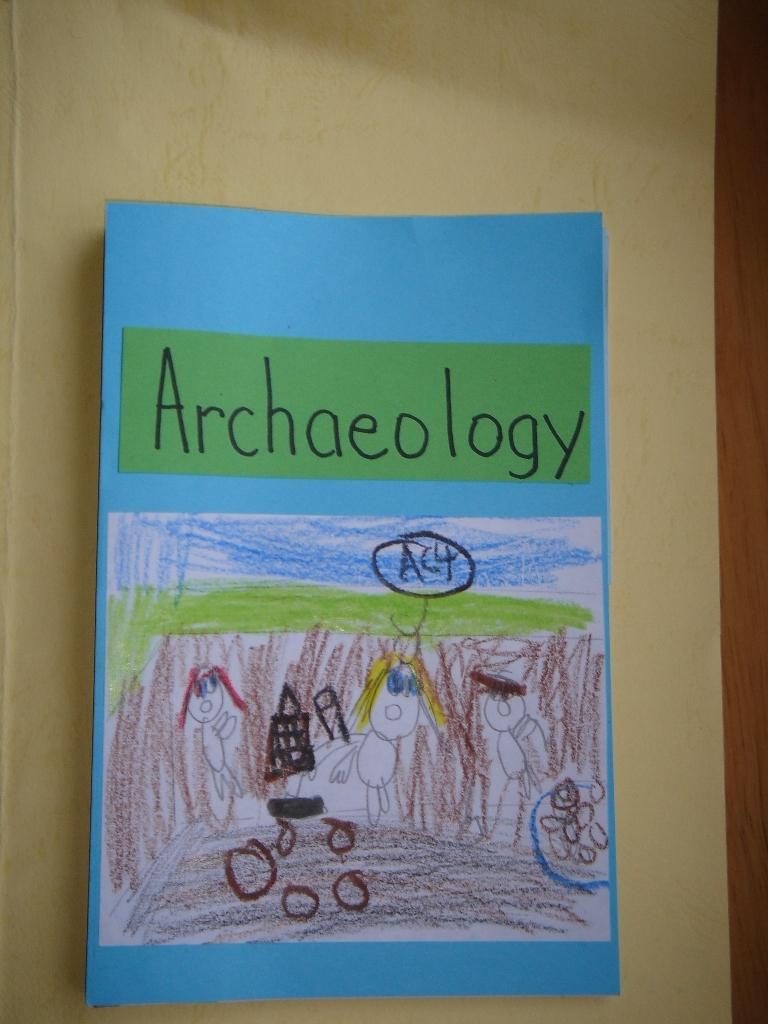Is the picture depicting excavation?
Ensure brevity in your answer.  Yes. 